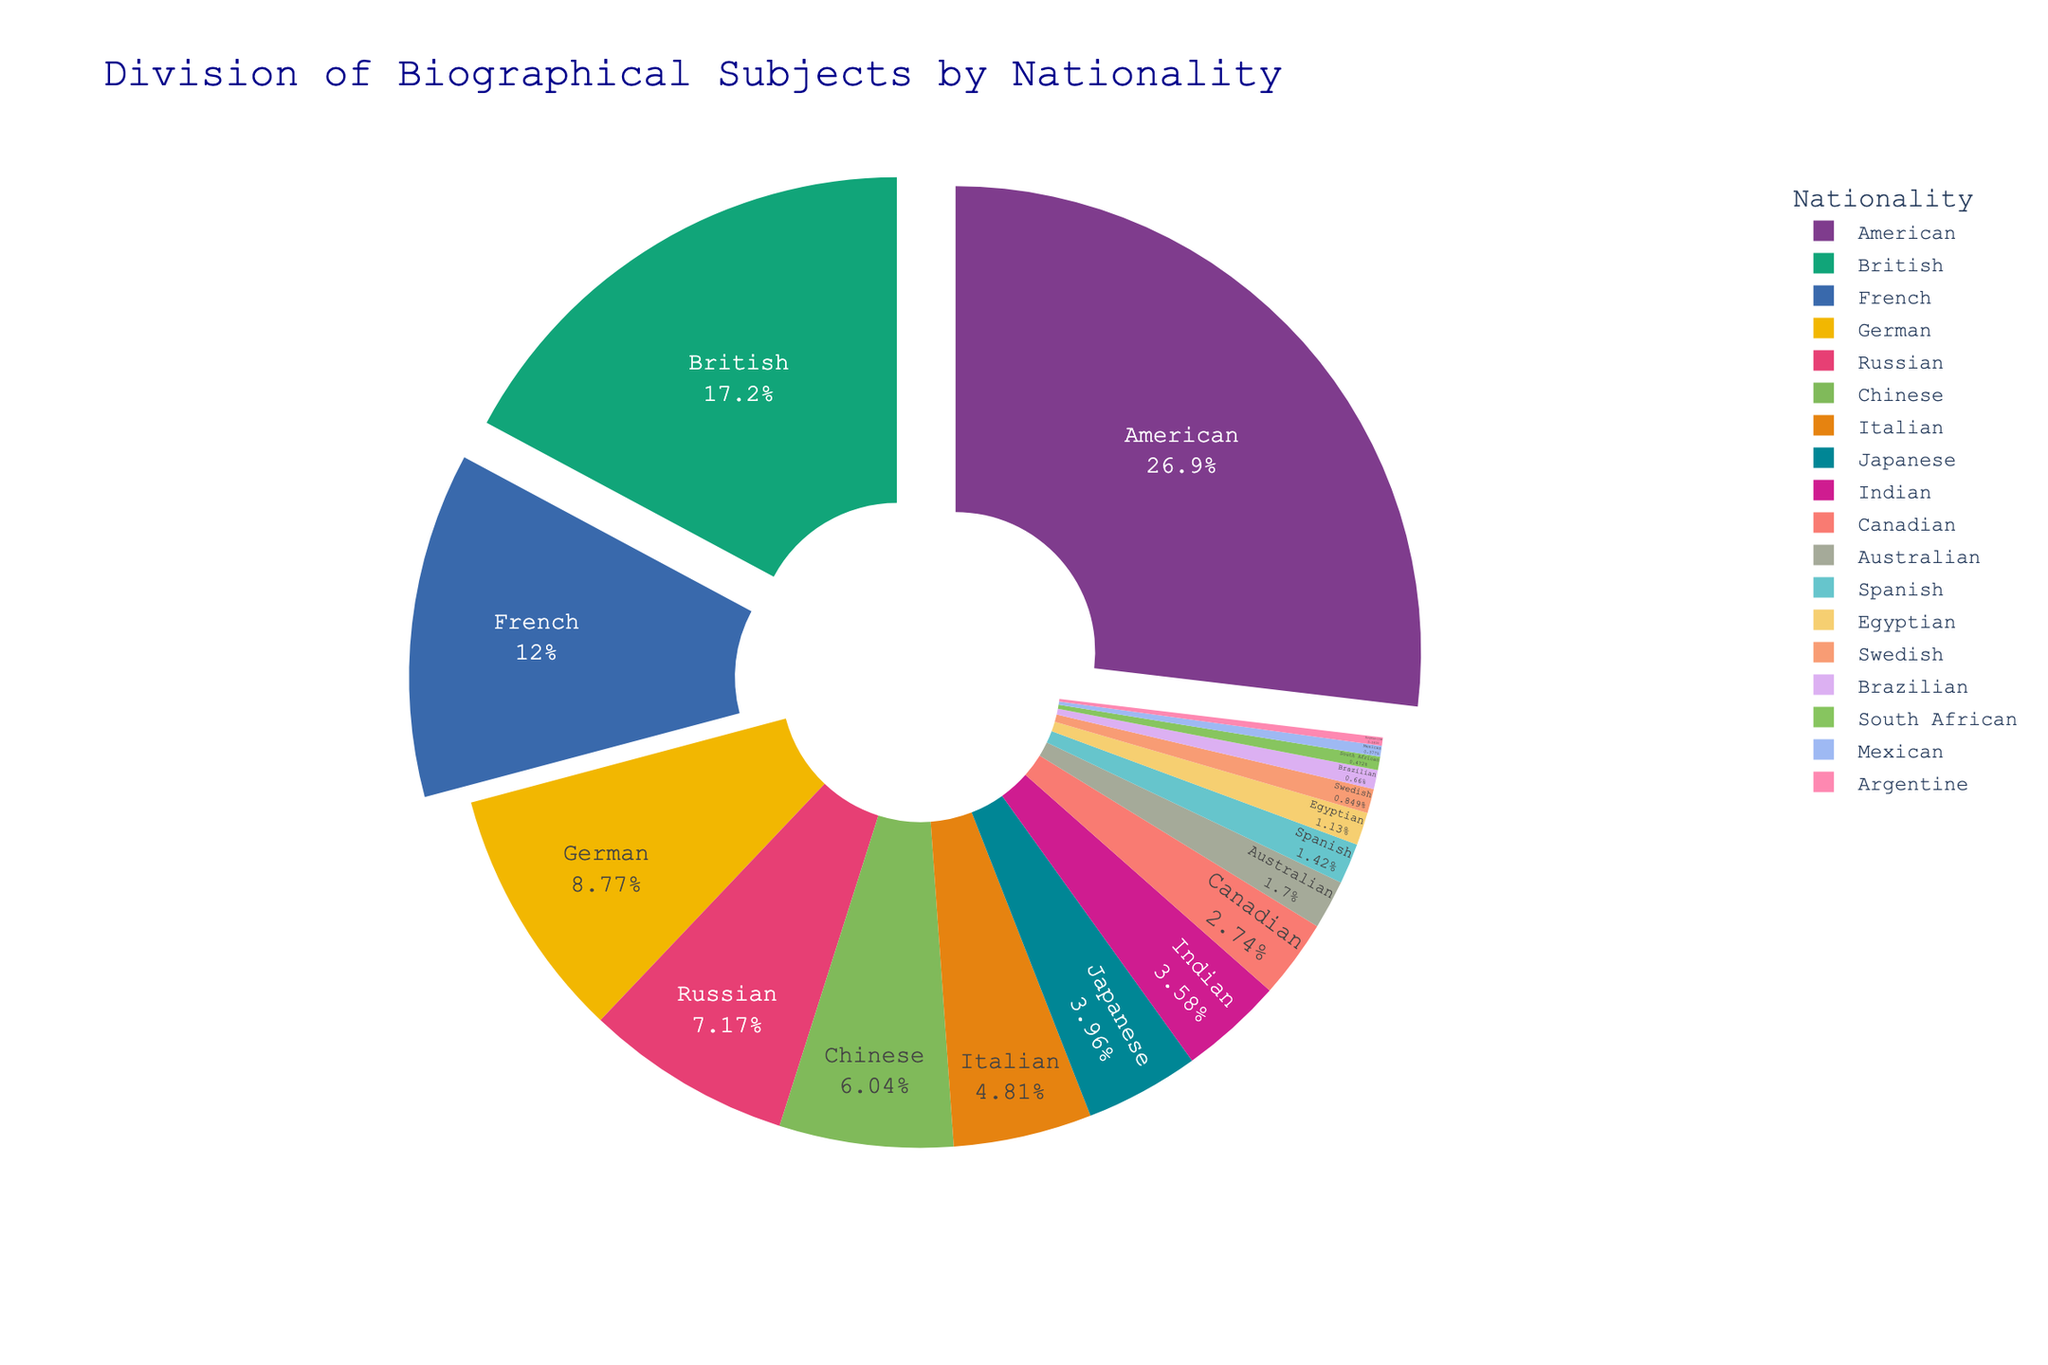Which nationality has the largest percentage of biographical subjects? Look at the nationality with the largest section in the pie chart. Its label inside the segment shows the percentage.
Answer: American What is the combined percentage of American and British biographical subjects? Identify the American percentage (28.5) and the British percentage (18.2), then add them together: 28.5 + 18.2.
Answer: 46.7 How does the percentage of French subjects compare with German subjects? Check the percentages for French (12.7) and German (9.3) in the pie chart and see which is larger.
Answer: French has a larger percentage than German Which segment is smaller: Chinese or Japanese? Compare the percentages labeled inside the Chinese segment (6.4) and the Japanese segment (4.2).
Answer: Japanese What’s the total percentage of the nationalities with less than 5% representation? Identify each nationality with a percentage less than 5%: Japanese (4.2), Indian (3.8), Canadian (2.9), Australian (1.8), Spanish (1.5), Egyptian (1.2), Swedish (0.9), Brazilian (0.7), South African (0.5), Mexican (0.4), Argentine (0.3). Sum these: 4.2 + 3.8 + 2.9 + 1.8 + 1.5 + 1.2 + 0.9 + 0.7 + 0.5 + 0.4 + 0.3 = 18.2.
Answer: 18.2 What percentage of biographical subjects are not American, British, or French? Subtract the combined percentage of American, British, and French from 100%: 100 - (28.5 + 18.2 + 12.7): 100 - 59.4 = 40.6.
Answer: 40.6 How does the visual emphasis reflect the importance of different nationalities in the pie chart? The most significant nationalities (above 10%) likely have segments that are pulled out from the center, highlighting their importance and making them more noticeable. American, British, and French segments should appear more prominently.
Answer: Larger segments are pulled out Identify two nationalities with close representation percentages. Look for nationalities with similar percentages. German (9.3%) and Russian (7.6%) are relatively close.
Answer: German and Russian Which nationality has the least percentage of biographical subjects in the collection? Find the smallest segment in the pie chart and check its label for the percentage, which is the Argentine segment (0.3%).
Answer: Argentine 